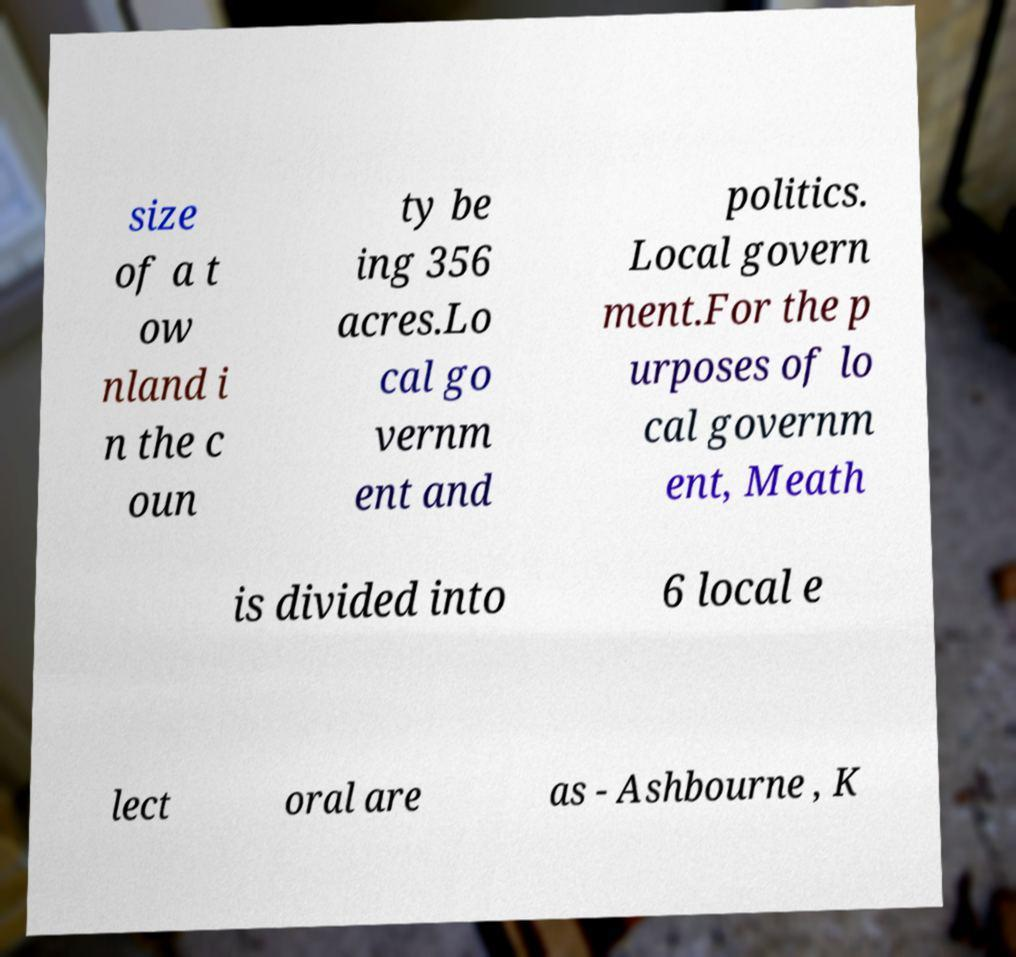What messages or text are displayed in this image? I need them in a readable, typed format. size of a t ow nland i n the c oun ty be ing 356 acres.Lo cal go vernm ent and politics. Local govern ment.For the p urposes of lo cal governm ent, Meath is divided into 6 local e lect oral are as - Ashbourne , K 